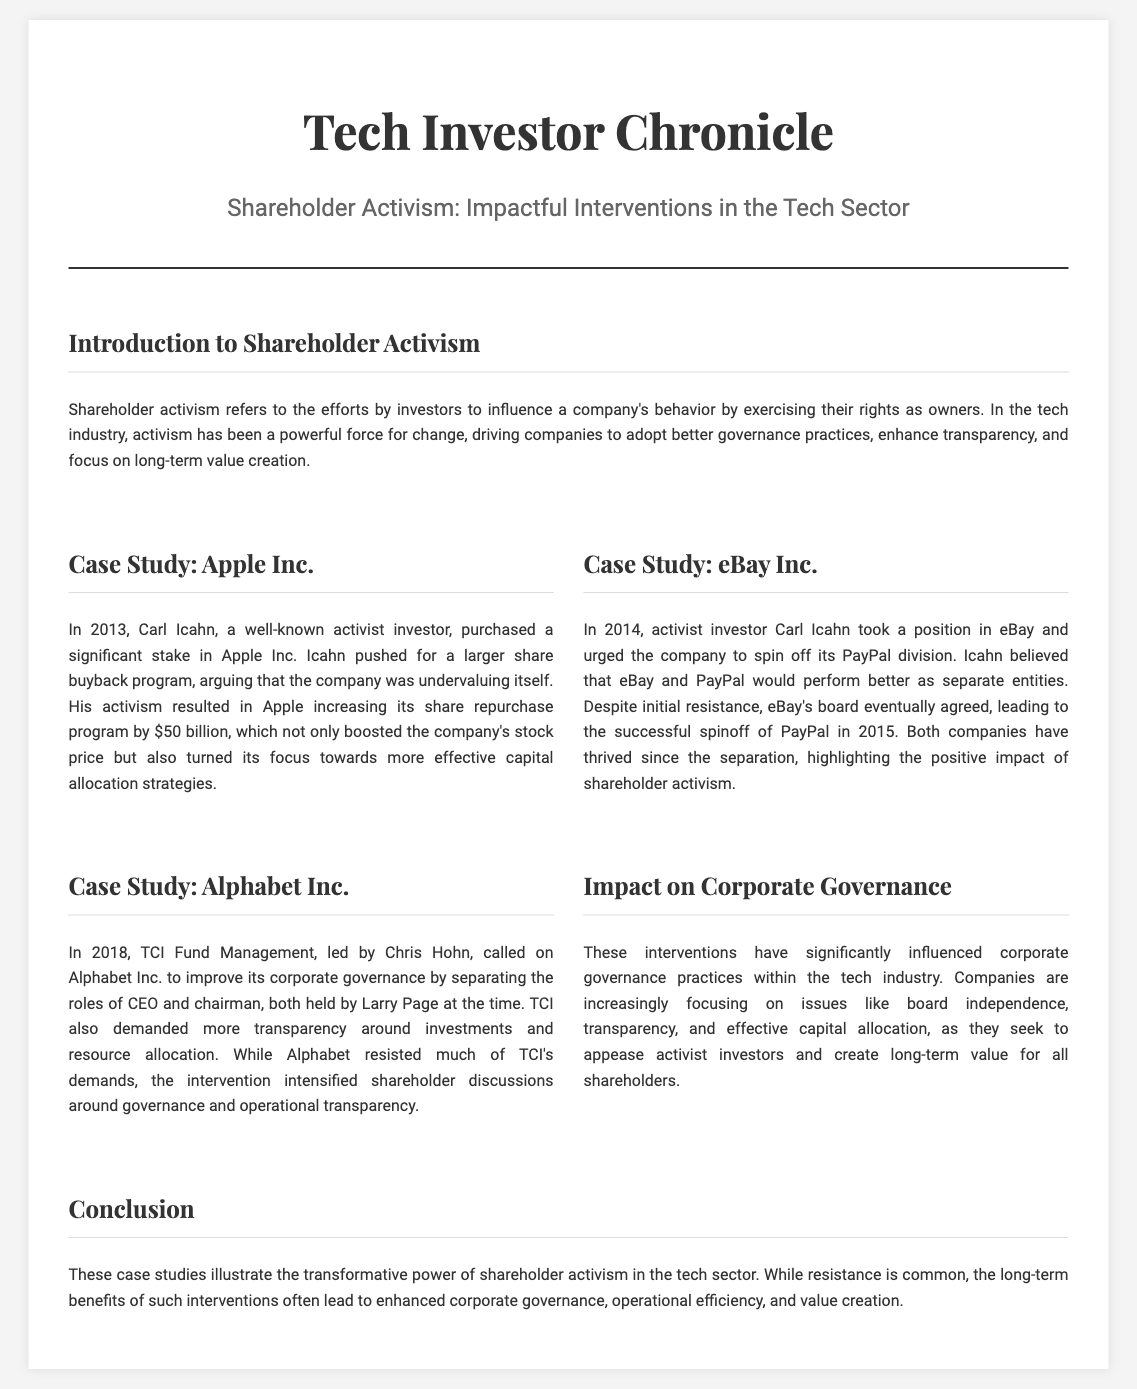What year did Carl Icahn purchase a stake in Apple Inc.? The document states that Carl Icahn purchased a stake in Apple Inc. in 2013.
Answer: 2013 What was the value of the share buyback program that Apple Inc. increased? The document mentions that Apple increased its share repurchase program by $50 billion.
Answer: $50 billion Which activist investor urged eBay to spin off PayPal? The document identifies Carl Icahn as the activist investor who urged eBay to spin off PayPal.
Answer: Carl Icahn What did TCI Fund Management demand from Alphabet Inc. in 2018? The document notes that TCI Fund Management called for improved corporate governance by separating the roles of CEO and chairman.
Answer: Separation of roles What positive outcome occurred following the eBay and PayPal spinoff? According to the document, both companies thrived after the separation, highlighting a positive outcome from the spinoff.
Answer: Thrived What is a significant impact of shareholder activism on corporate governance? The document states that activist interventions have influenced practices like board independence, transparency, and effective capital allocation.
Answer: Enhanced governance practices What is the overall conclusion regarding shareholder activism in the tech sector? The document concludes that shareholder activism often leads to enhanced corporate governance, operational efficiency, and value creation.
Answer: Transformative power What type of document is "Tech Investor Chronicle"? The format and content suggest it is a newspaper layout focused on shareholder activism in tech companies.
Answer: Newspaper layout 